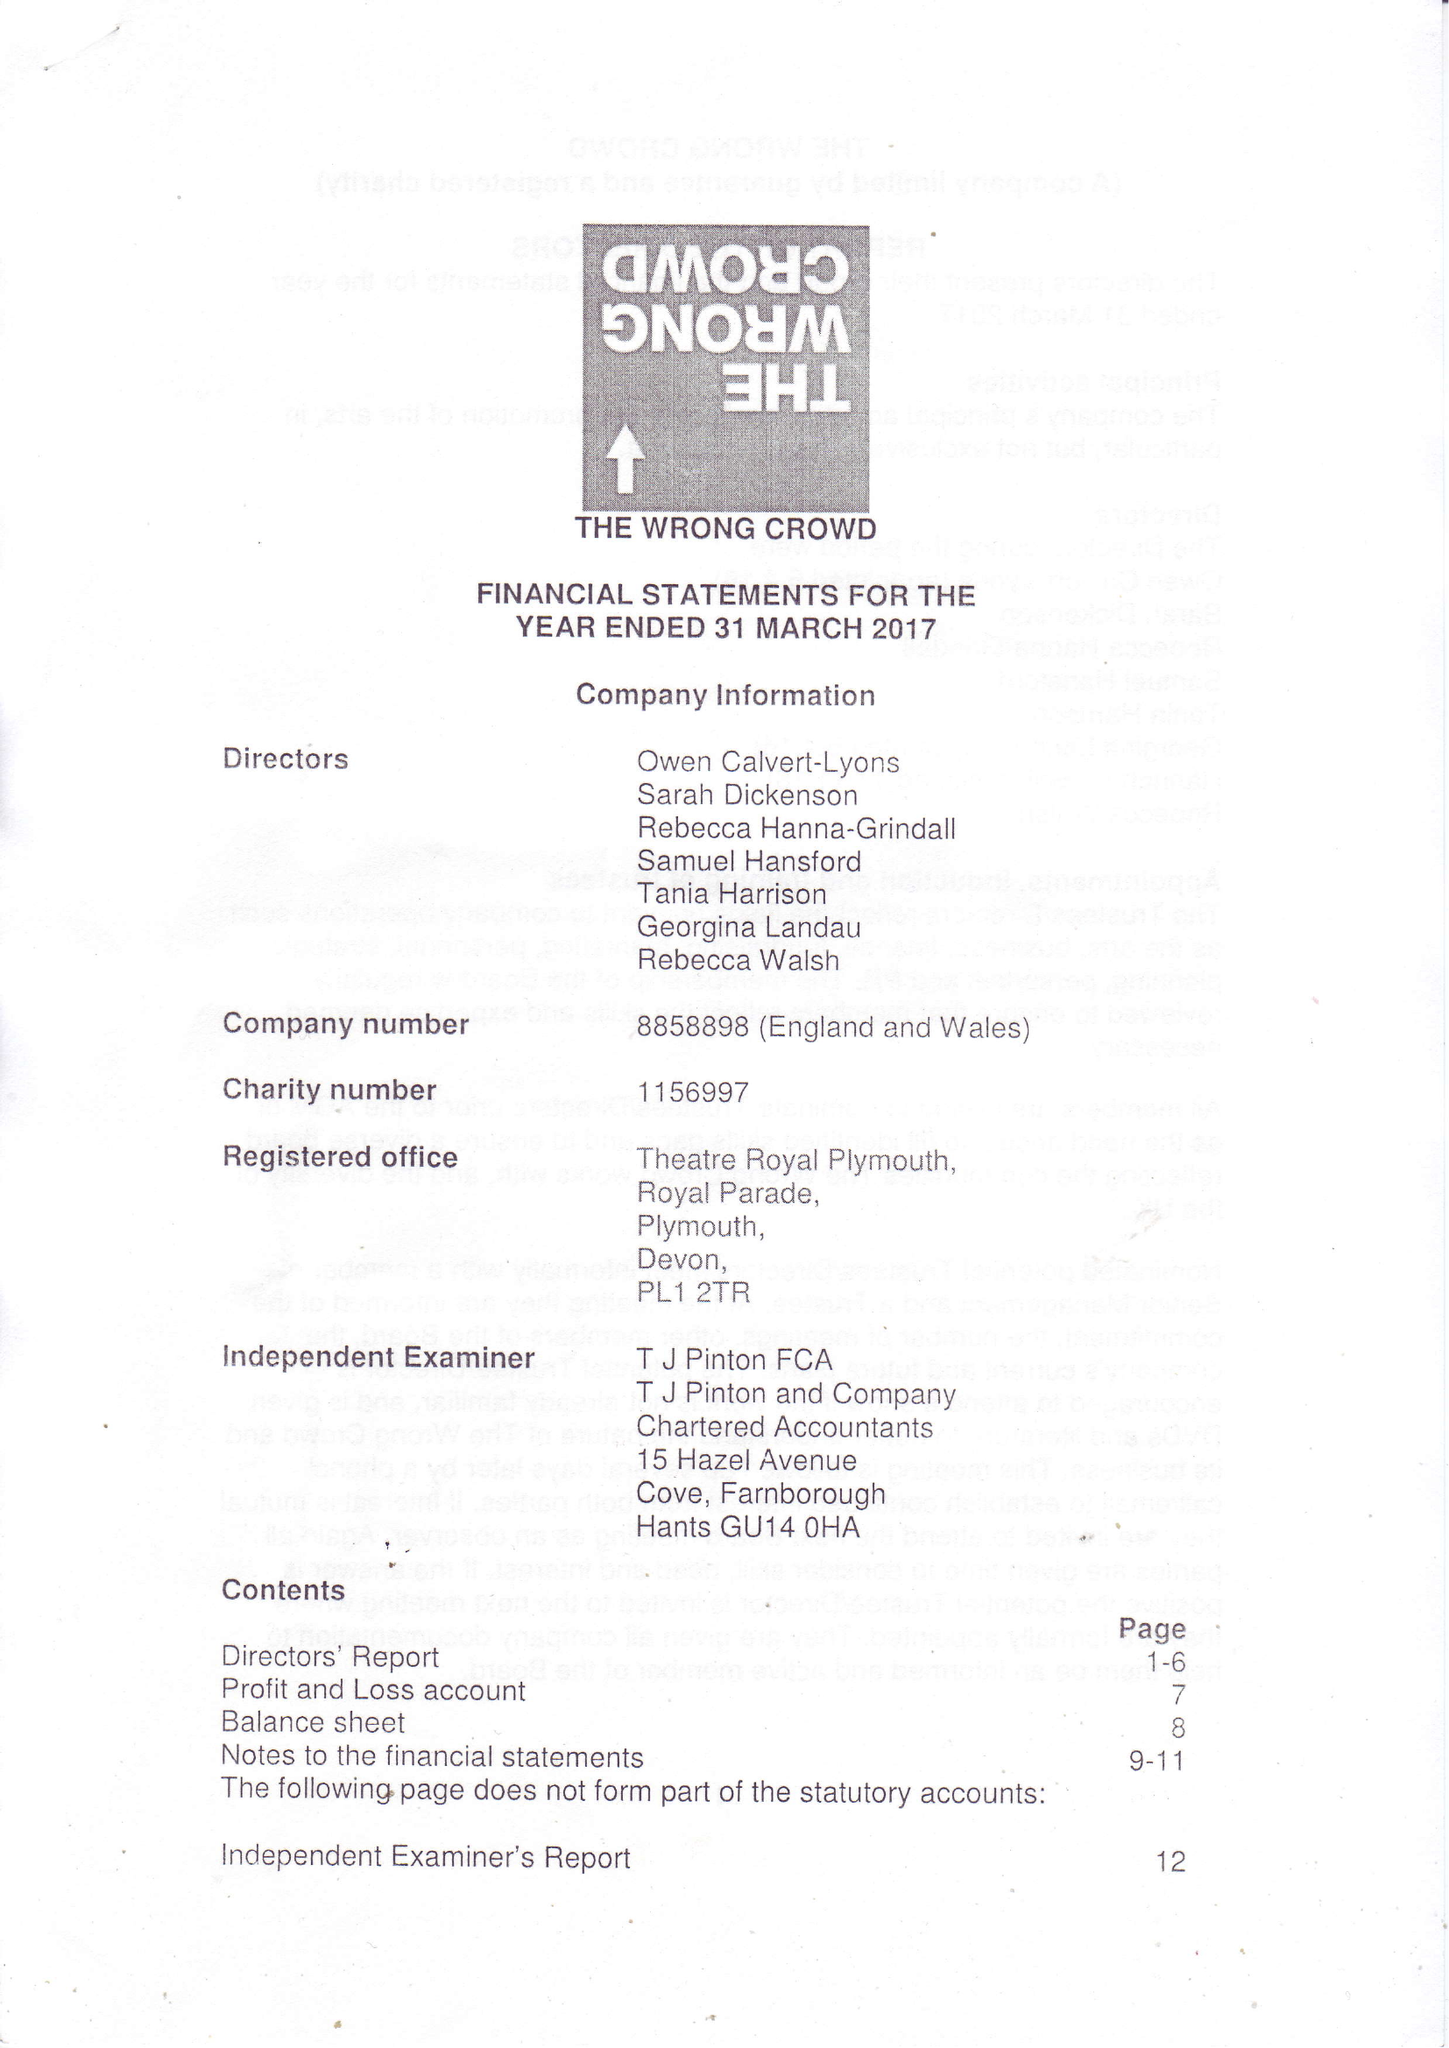What is the value for the address__post_town?
Answer the question using a single word or phrase. SOUTH BRENT 